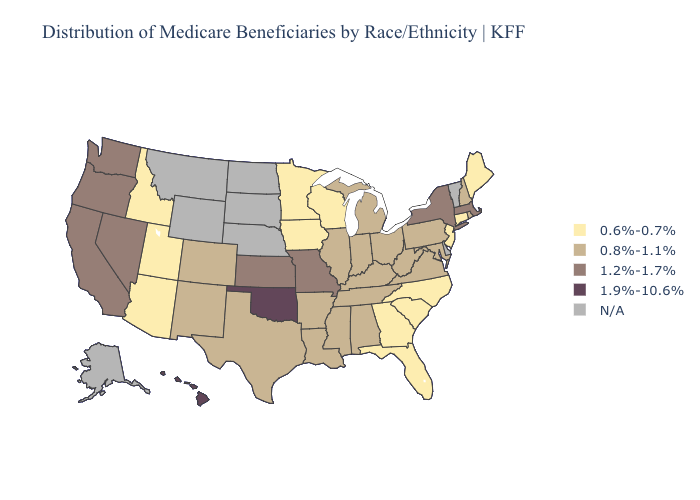Among the states that border Delaware , which have the lowest value?
Write a very short answer. New Jersey. Does Rhode Island have the highest value in the Northeast?
Give a very brief answer. No. Name the states that have a value in the range 0.8%-1.1%?
Short answer required. Alabama, Arkansas, Colorado, Illinois, Indiana, Kentucky, Louisiana, Maryland, Michigan, Mississippi, New Hampshire, New Mexico, Ohio, Pennsylvania, Rhode Island, Tennessee, Texas, Virginia, West Virginia. What is the highest value in the Northeast ?
Concise answer only. 1.2%-1.7%. Which states have the lowest value in the USA?
Answer briefly. Arizona, Connecticut, Florida, Georgia, Idaho, Iowa, Maine, Minnesota, New Jersey, North Carolina, South Carolina, Utah, Wisconsin. Which states hav the highest value in the MidWest?
Be succinct. Kansas, Missouri. Name the states that have a value in the range 0.8%-1.1%?
Write a very short answer. Alabama, Arkansas, Colorado, Illinois, Indiana, Kentucky, Louisiana, Maryland, Michigan, Mississippi, New Hampshire, New Mexico, Ohio, Pennsylvania, Rhode Island, Tennessee, Texas, Virginia, West Virginia. What is the lowest value in states that border South Carolina?
Concise answer only. 0.6%-0.7%. Name the states that have a value in the range 1.9%-10.6%?
Answer briefly. Hawaii, Oklahoma. What is the value of Pennsylvania?
Give a very brief answer. 0.8%-1.1%. Name the states that have a value in the range 1.2%-1.7%?
Concise answer only. California, Kansas, Massachusetts, Missouri, Nevada, New York, Oregon, Washington. Name the states that have a value in the range 0.6%-0.7%?
Keep it brief. Arizona, Connecticut, Florida, Georgia, Idaho, Iowa, Maine, Minnesota, New Jersey, North Carolina, South Carolina, Utah, Wisconsin. 